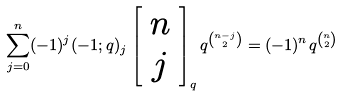<formula> <loc_0><loc_0><loc_500><loc_500>\sum _ { j = 0 } ^ { n } ( - 1 ) ^ { j } ( - 1 ; q ) _ { j } \left [ \begin{array} { c } n \\ j \end{array} \right ] _ { q } q ^ { { n - j } \choose 2 } = ( - 1 ) ^ { n } q ^ { n \choose 2 }</formula> 